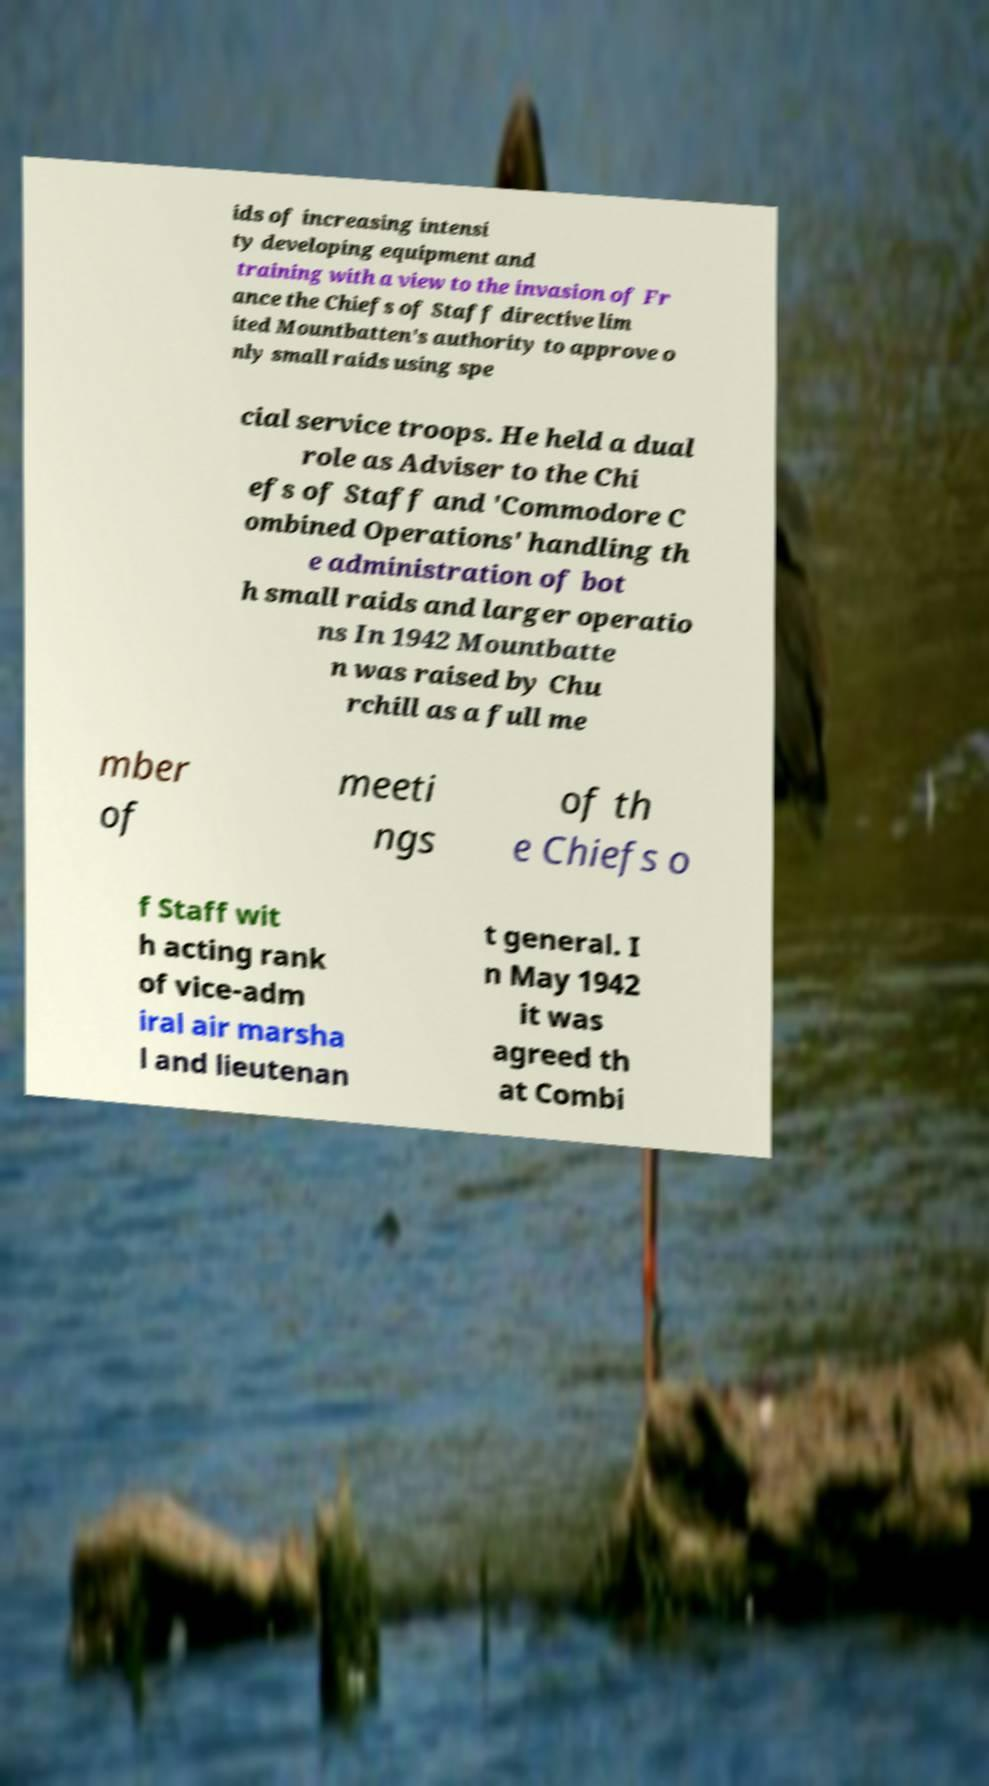For documentation purposes, I need the text within this image transcribed. Could you provide that? ids of increasing intensi ty developing equipment and training with a view to the invasion of Fr ance the Chiefs of Staff directive lim ited Mountbatten's authority to approve o nly small raids using spe cial service troops. He held a dual role as Adviser to the Chi efs of Staff and 'Commodore C ombined Operations' handling th e administration of bot h small raids and larger operatio ns In 1942 Mountbatte n was raised by Chu rchill as a full me mber of meeti ngs of th e Chiefs o f Staff wit h acting rank of vice-adm iral air marsha l and lieutenan t general. I n May 1942 it was agreed th at Combi 